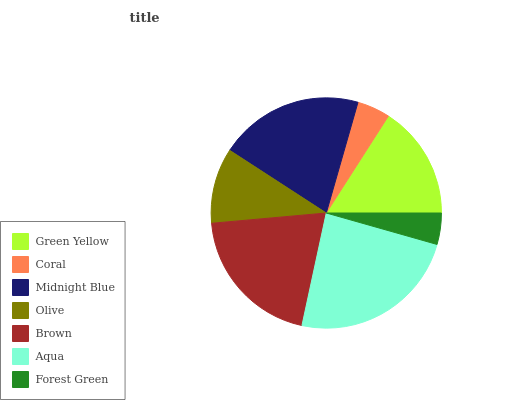Is Forest Green the minimum?
Answer yes or no. Yes. Is Aqua the maximum?
Answer yes or no. Yes. Is Coral the minimum?
Answer yes or no. No. Is Coral the maximum?
Answer yes or no. No. Is Green Yellow greater than Coral?
Answer yes or no. Yes. Is Coral less than Green Yellow?
Answer yes or no. Yes. Is Coral greater than Green Yellow?
Answer yes or no. No. Is Green Yellow less than Coral?
Answer yes or no. No. Is Green Yellow the high median?
Answer yes or no. Yes. Is Green Yellow the low median?
Answer yes or no. Yes. Is Forest Green the high median?
Answer yes or no. No. Is Olive the low median?
Answer yes or no. No. 